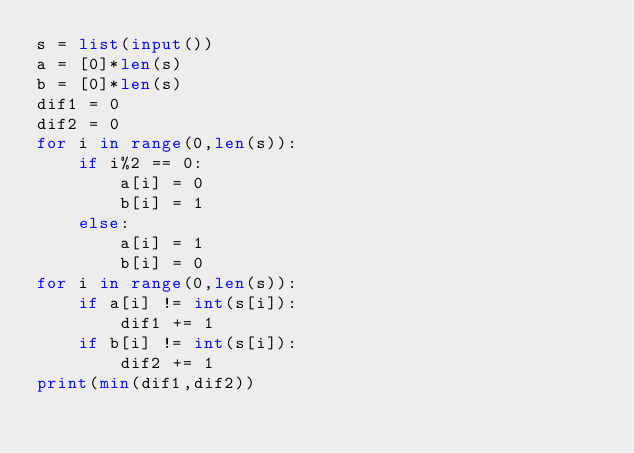Convert code to text. <code><loc_0><loc_0><loc_500><loc_500><_Python_>s = list(input())
a = [0]*len(s)
b = [0]*len(s)
dif1 = 0
dif2 = 0
for i in range(0,len(s)):
    if i%2 == 0:
        a[i] = 0
        b[i] = 1
    else:
        a[i] = 1
        b[i] = 0
for i in range(0,len(s)):
    if a[i] != int(s[i]):
        dif1 += 1
    if b[i] != int(s[i]):
        dif2 += 1
print(min(dif1,dif2))
</code> 